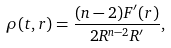<formula> <loc_0><loc_0><loc_500><loc_500>\rho ( t , r ) = \frac { ( n - 2 ) F ^ { \prime } ( r ) } { 2 R ^ { n - 2 } R ^ { \prime } } ,</formula> 